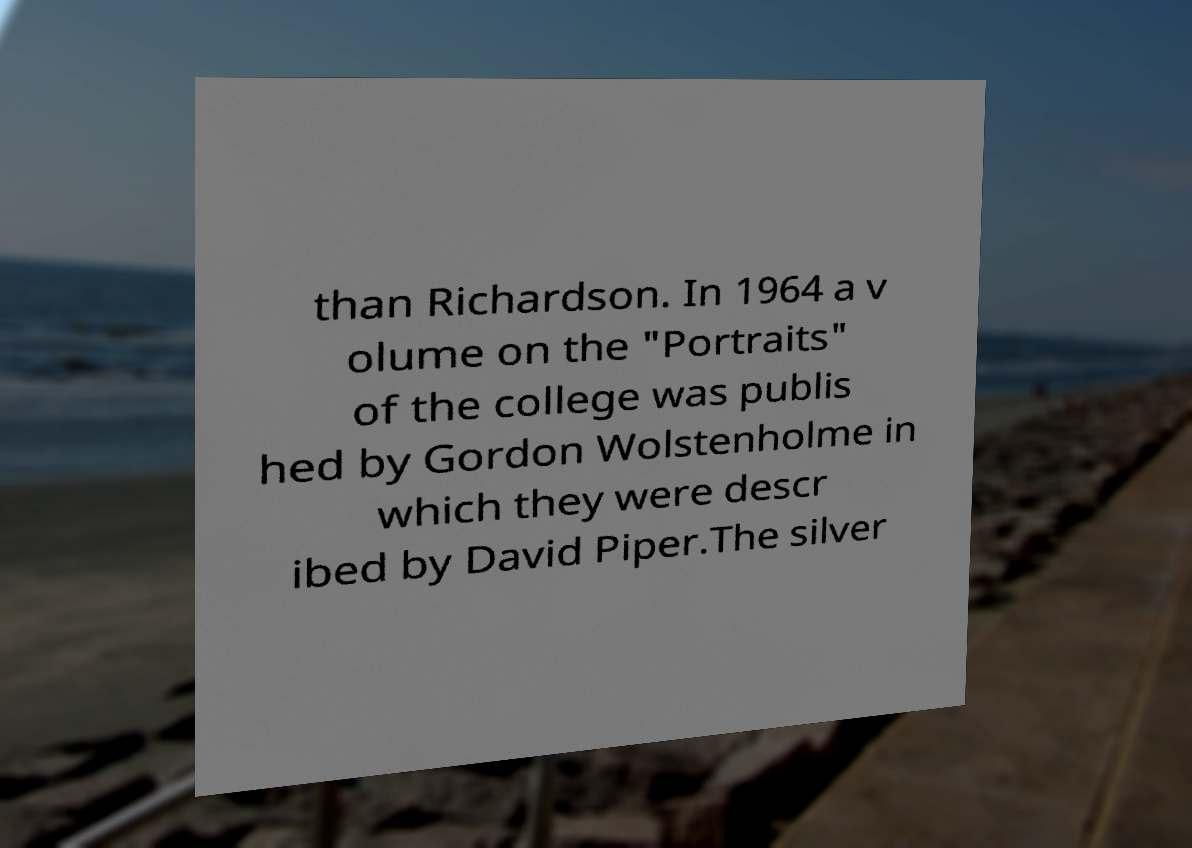Could you assist in decoding the text presented in this image and type it out clearly? than Richardson. In 1964 a v olume on the "Portraits" of the college was publis hed by Gordon Wolstenholme in which they were descr ibed by David Piper.The silver 